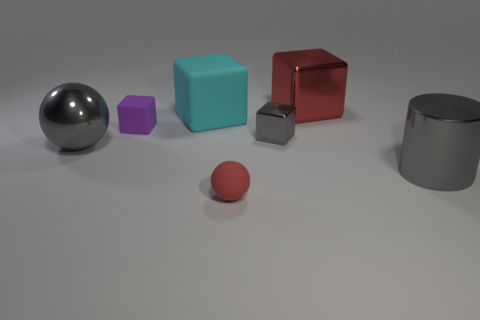What is the size of the rubber thing that is both on the right side of the purple matte object and behind the tiny metal thing?
Offer a very short reply. Large. How many gray cubes are the same size as the shiny ball?
Keep it short and to the point. 0. There is a metallic object that is on the right side of the big object that is behind the large cyan block; what is its size?
Keep it short and to the point. Large. Is the shape of the big gray shiny object that is on the right side of the small gray metal block the same as the gray metal object behind the gray ball?
Keep it short and to the point. No. The big shiny object that is on the left side of the gray shiny cylinder and to the right of the cyan matte thing is what color?
Your response must be concise. Red. Are there any tiny matte objects that have the same color as the shiny ball?
Your answer should be very brief. No. What color is the large metal cylinder that is behind the small rubber sphere?
Give a very brief answer. Gray. There is a matte sphere that is right of the purple cube; are there any big gray objects that are in front of it?
Your answer should be very brief. No. Does the big matte thing have the same color as the shiny block in front of the big shiny cube?
Make the answer very short. No. Are there any large cyan things made of the same material as the big gray ball?
Your response must be concise. No. 